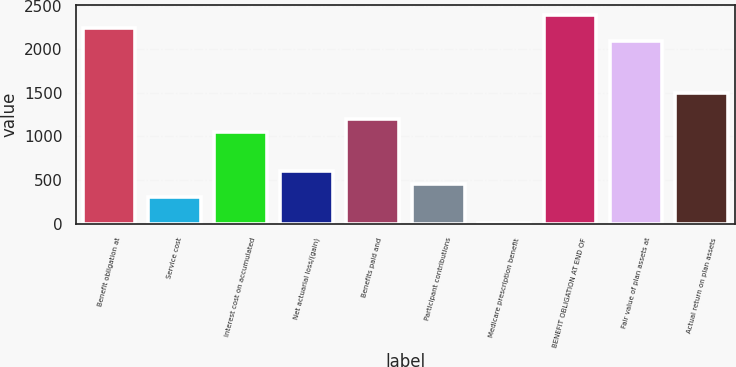Convert chart. <chart><loc_0><loc_0><loc_500><loc_500><bar_chart><fcel>Benefit obligation at<fcel>Service cost<fcel>Interest cost on accumulated<fcel>Net actuarial loss/(gain)<fcel>Benefits paid and<fcel>Participant contributions<fcel>Medicare prescription benefit<fcel>BENEFIT OBLIGATION AT END OF<fcel>Fair value of plan assets at<fcel>Actual return on plan assets<nl><fcel>2240<fcel>303<fcel>1048<fcel>601<fcel>1197<fcel>452<fcel>5<fcel>2389<fcel>2091<fcel>1495<nl></chart> 